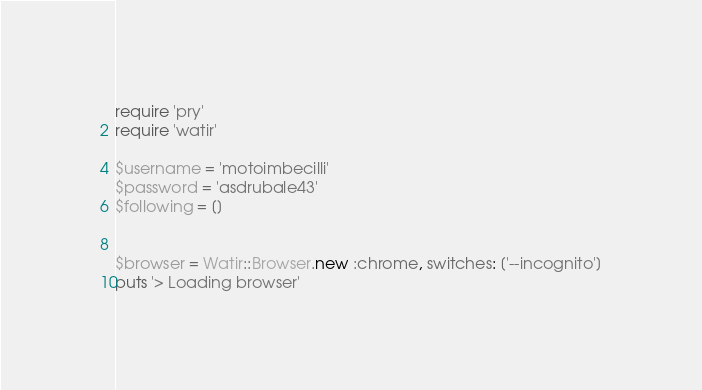Convert code to text. <code><loc_0><loc_0><loc_500><loc_500><_Ruby_>require 'pry'
require 'watir'

$username = 'motoimbecilli'
$password = 'asdrubale43'
$following = []


$browser = Watir::Browser.new :chrome, switches: ['--incognito']
puts '> Loading browser'</code> 